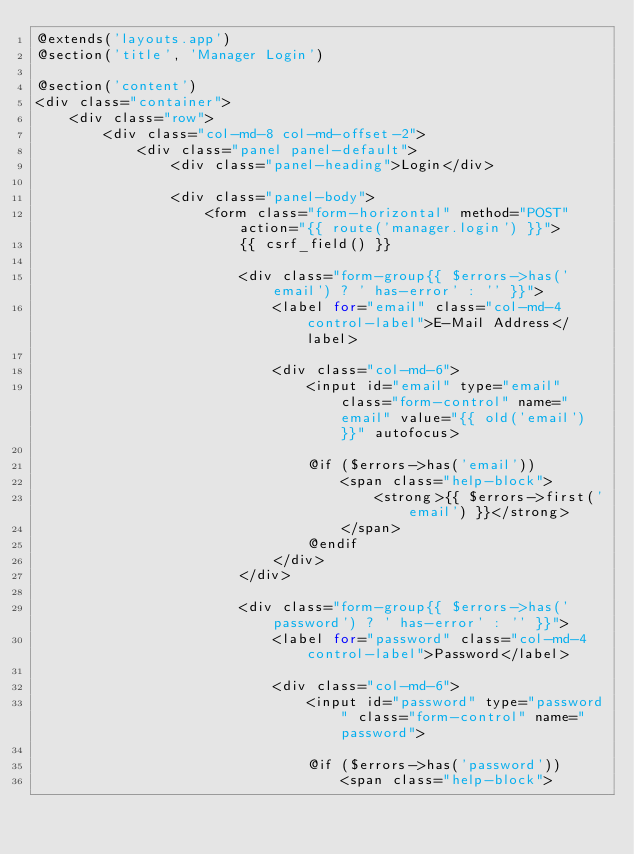<code> <loc_0><loc_0><loc_500><loc_500><_PHP_>@extends('layouts.app')
@section('title', 'Manager Login')

@section('content')
<div class="container">
    <div class="row">
        <div class="col-md-8 col-md-offset-2">
            <div class="panel panel-default">
                <div class="panel-heading">Login</div>

                <div class="panel-body">
                    <form class="form-horizontal" method="POST" action="{{ route('manager.login') }}">
                        {{ csrf_field() }}

                        <div class="form-group{{ $errors->has('email') ? ' has-error' : '' }}">
                            <label for="email" class="col-md-4 control-label">E-Mail Address</label>

                            <div class="col-md-6">
                                <input id="email" type="email" class="form-control" name="email" value="{{ old('email') }}" autofocus>

                                @if ($errors->has('email'))
                                    <span class="help-block">
                                        <strong>{{ $errors->first('email') }}</strong>
                                    </span>
                                @endif
                            </div>
                        </div>

                        <div class="form-group{{ $errors->has('password') ? ' has-error' : '' }}">
                            <label for="password" class="col-md-4 control-label">Password</label>

                            <div class="col-md-6">
                                <input id="password" type="password" class="form-control" name="password">

                                @if ($errors->has('password'))
                                    <span class="help-block"></code> 